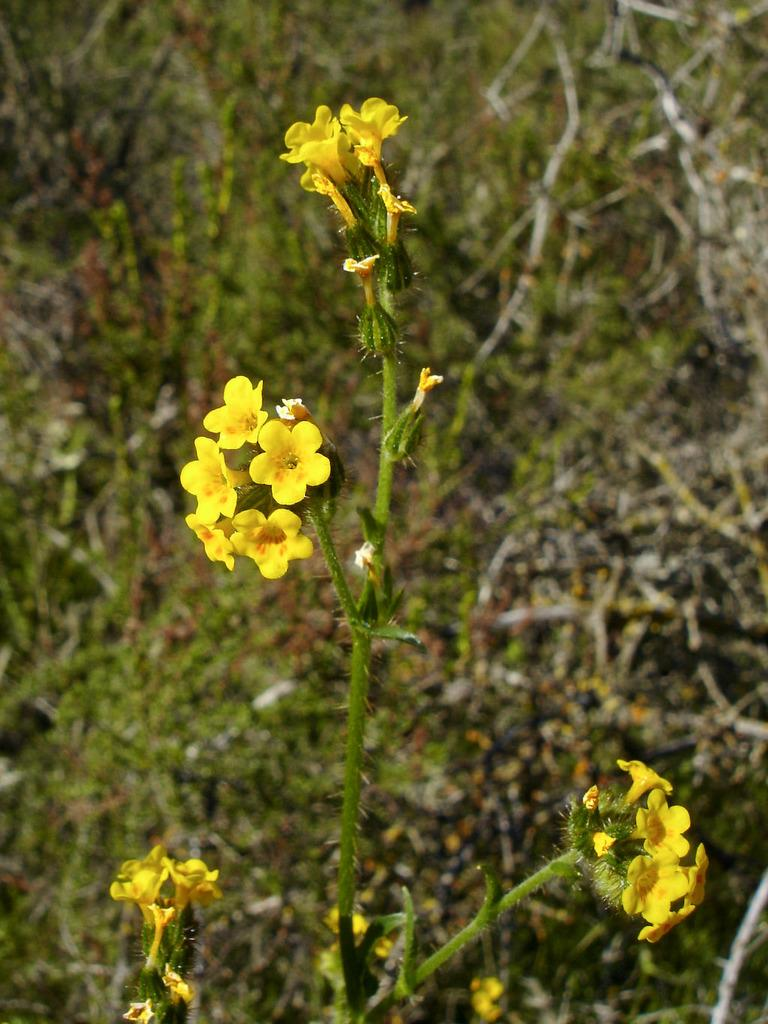What type of plant is in the image? There is a plant in the image with yellow flowers. What stage of growth are the flowers in? The plant has buds, indicating that the flowers are not fully bloomed yet. Can you describe the plants in the background of the image? The background plants are green in color. How many plants are visible in the image? There is one plant in the foreground and more plants in the background. What type of attraction can be seen in the background of the image? There is no attraction present in the image; it features plants and flowers. Can you tell me how many books are on the shelf in the library in the image? There is no library or shelf with books present in the image. 